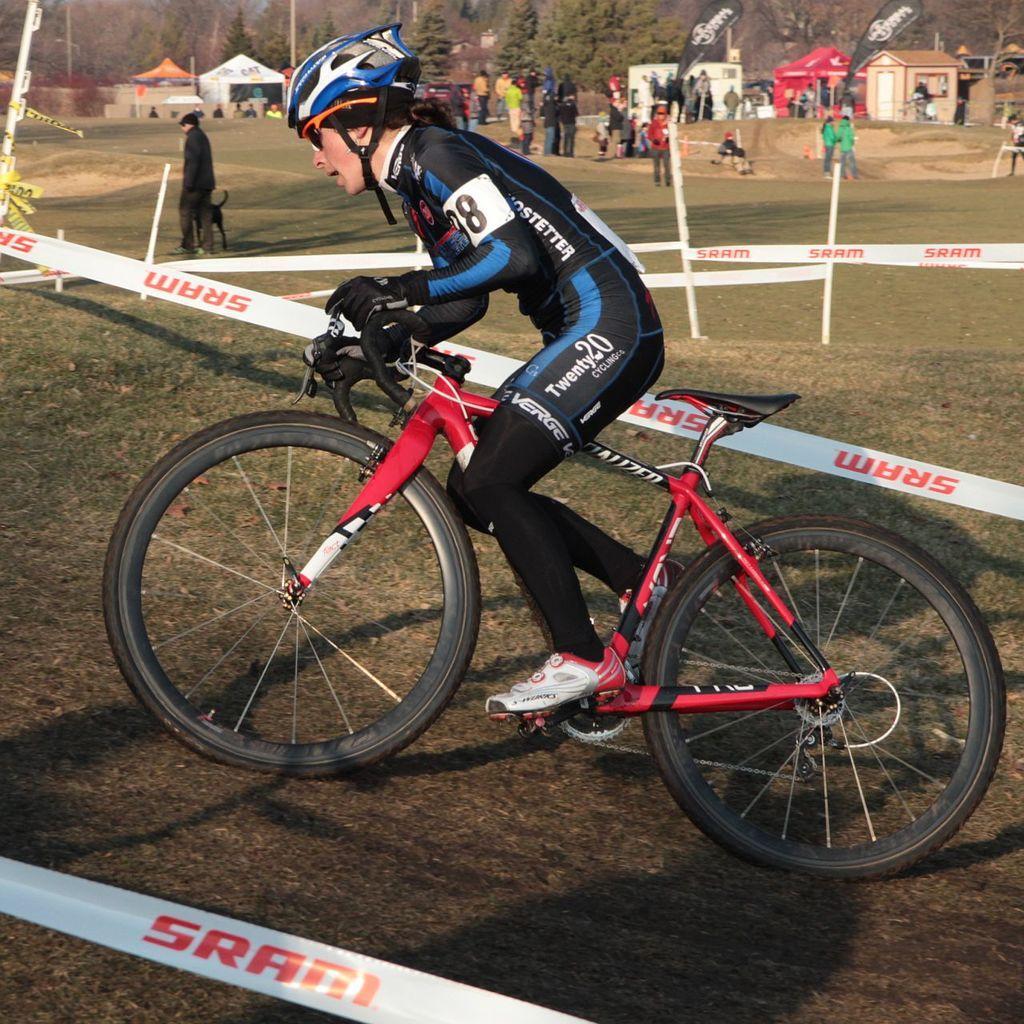Could you give a brief overview of what you see in this image? In the foreground of this image, there is a person riding a bicycle on the ground. On either side, there are barrier tapes to the poles. In the background, there are people walking and standing on the ground, banner flags, hut like structures, tents and the trees. 